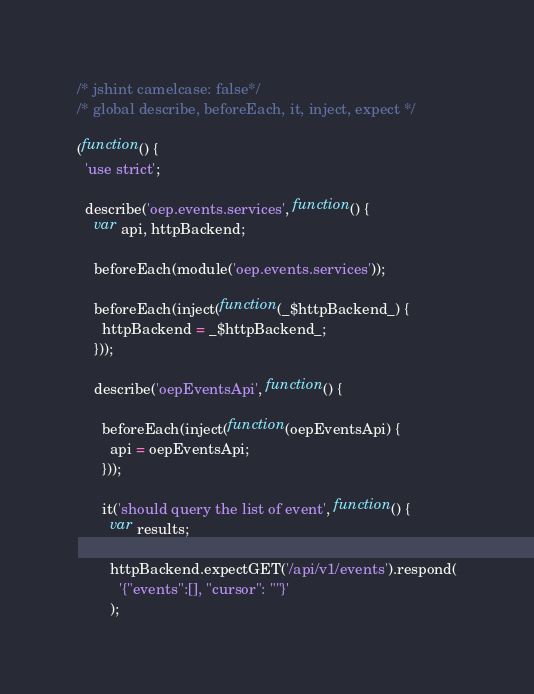<code> <loc_0><loc_0><loc_500><loc_500><_JavaScript_>/* jshint camelcase: false*/
/* global describe, beforeEach, it, inject, expect */

(function() {
  'use strict';

  describe('oep.events.services', function() {
    var api, httpBackend;

    beforeEach(module('oep.events.services'));

    beforeEach(inject(function(_$httpBackend_) {
      httpBackend = _$httpBackend_;
    }));

    describe('oepEventsApi', function() {

      beforeEach(inject(function(oepEventsApi) {
        api = oepEventsApi;
      }));

      it('should query the list of event', function() {
        var results;

        httpBackend.expectGET('/api/v1/events').respond(
          '{"events":[], "cursor": ""}'
        );
</code> 